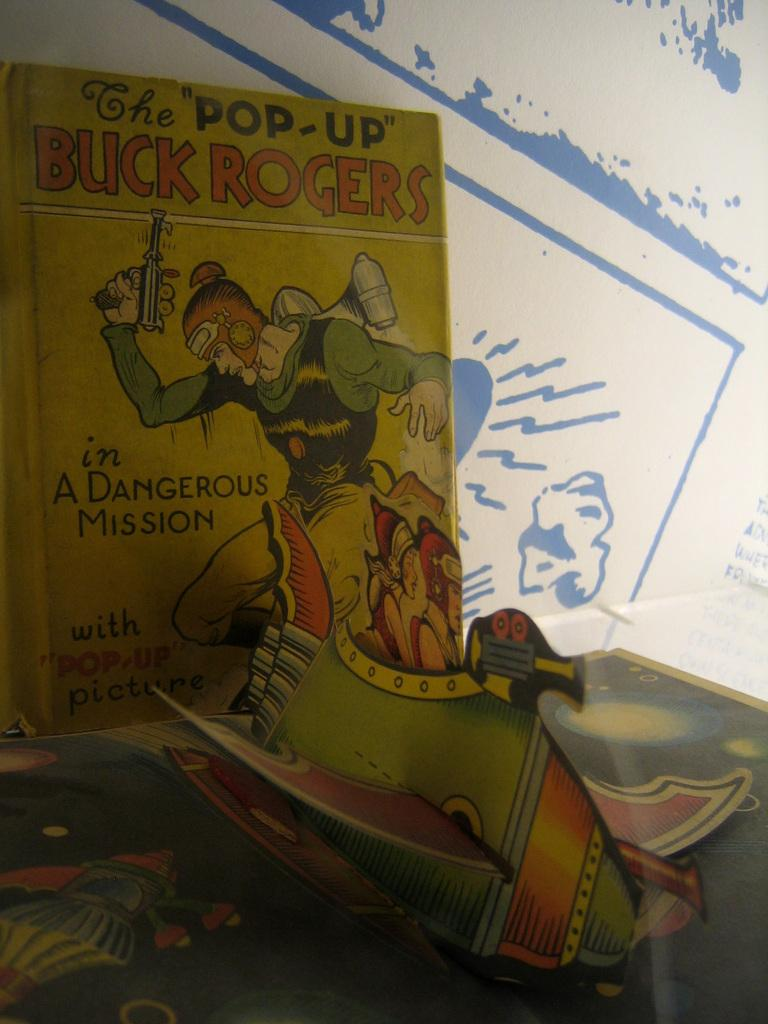<image>
Share a concise interpretation of the image provided. A Buck Rogers book has a man with a gun on the cover. 